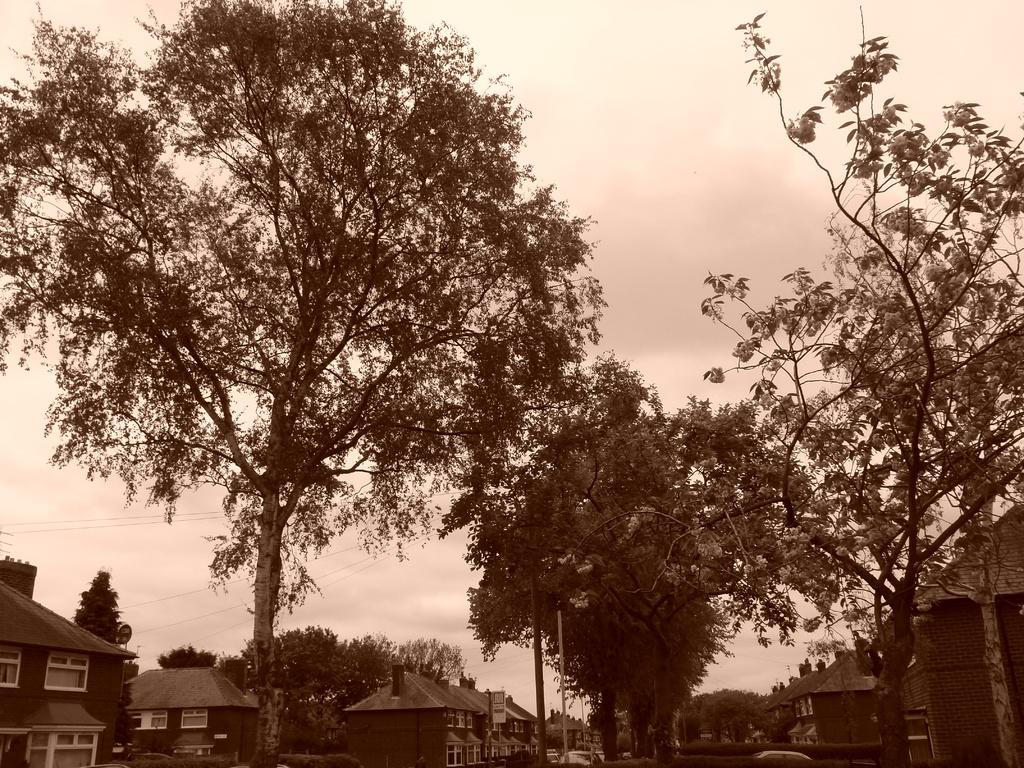What type of structures are visible in the image? There are houses in the image. What can be seen in the background of the image? There are trees and clouds in the sky in the background of the image. What is the color scheme of the image? The image is in black and white color. Are there any friends hanging out with the bee in the image? There is no bee or friends present in the image; it features houses, trees, and clouds in a black and white color scheme. 